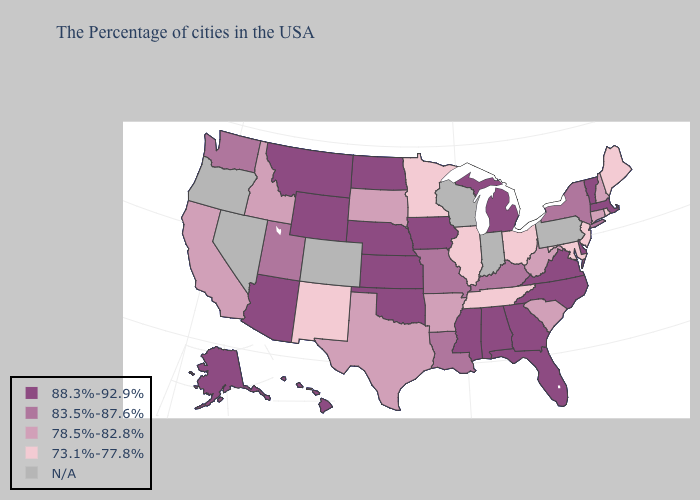Does Rhode Island have the lowest value in the USA?
Concise answer only. Yes. Which states hav the highest value in the West?
Give a very brief answer. Wyoming, Montana, Arizona, Alaska, Hawaii. What is the lowest value in states that border Tennessee?
Quick response, please. 78.5%-82.8%. Does the first symbol in the legend represent the smallest category?
Concise answer only. No. Does Illinois have the lowest value in the USA?
Keep it brief. Yes. Name the states that have a value in the range 73.1%-77.8%?
Give a very brief answer. Maine, Rhode Island, New Jersey, Maryland, Ohio, Tennessee, Illinois, Minnesota, New Mexico. What is the value of Wyoming?
Quick response, please. 88.3%-92.9%. Name the states that have a value in the range 88.3%-92.9%?
Concise answer only. Massachusetts, Vermont, Delaware, Virginia, North Carolina, Florida, Georgia, Michigan, Alabama, Mississippi, Iowa, Kansas, Nebraska, Oklahoma, North Dakota, Wyoming, Montana, Arizona, Alaska, Hawaii. What is the value of Indiana?
Give a very brief answer. N/A. What is the highest value in the USA?
Keep it brief. 88.3%-92.9%. What is the highest value in states that border North Carolina?
Answer briefly. 88.3%-92.9%. Among the states that border North Dakota , does Minnesota have the highest value?
Be succinct. No. Name the states that have a value in the range N/A?
Give a very brief answer. Pennsylvania, Indiana, Wisconsin, Colorado, Nevada, Oregon. Among the states that border Utah , does Idaho have the highest value?
Be succinct. No. 